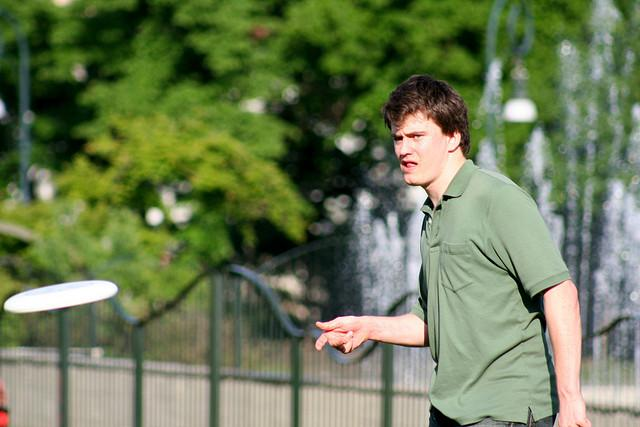The color of the shirt matches the color of what? Please explain your reasoning. money. Paper dollars are green. 